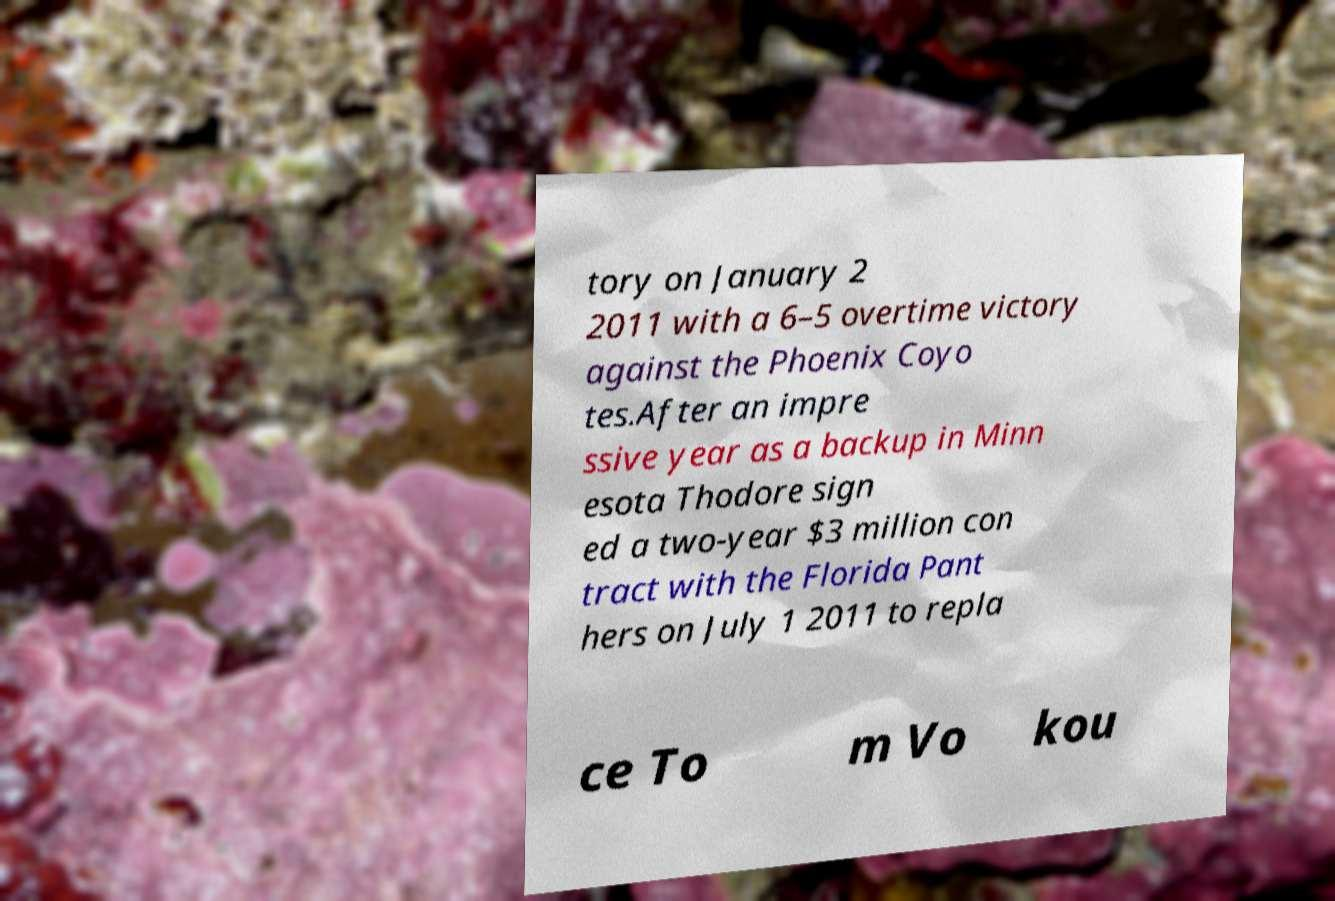For documentation purposes, I need the text within this image transcribed. Could you provide that? tory on January 2 2011 with a 6–5 overtime victory against the Phoenix Coyo tes.After an impre ssive year as a backup in Minn esota Thodore sign ed a two-year $3 million con tract with the Florida Pant hers on July 1 2011 to repla ce To m Vo kou 